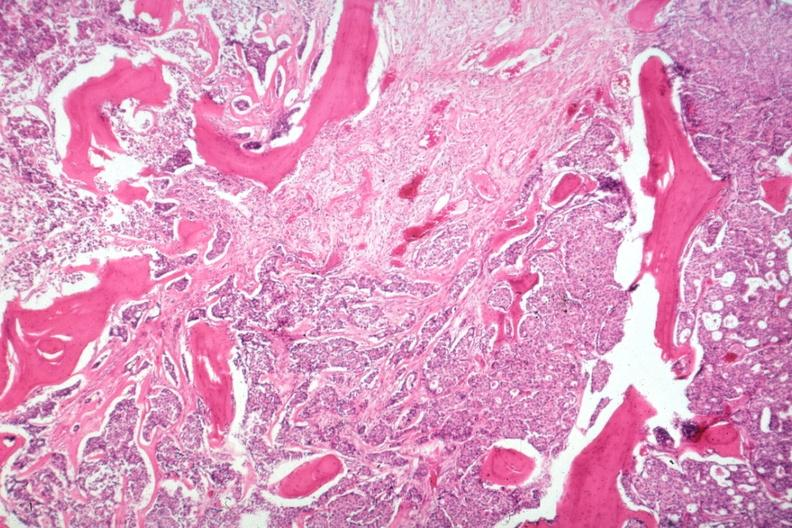what is present?
Answer the question using a single word or phrase. Joints 